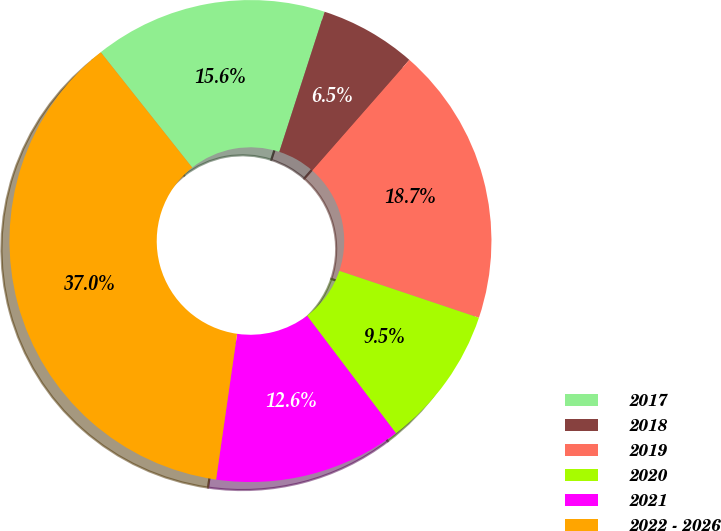Convert chart. <chart><loc_0><loc_0><loc_500><loc_500><pie_chart><fcel>2017<fcel>2018<fcel>2019<fcel>2020<fcel>2021<fcel>2022 - 2026<nl><fcel>15.65%<fcel>6.48%<fcel>18.7%<fcel>9.53%<fcel>12.59%<fcel>37.05%<nl></chart> 